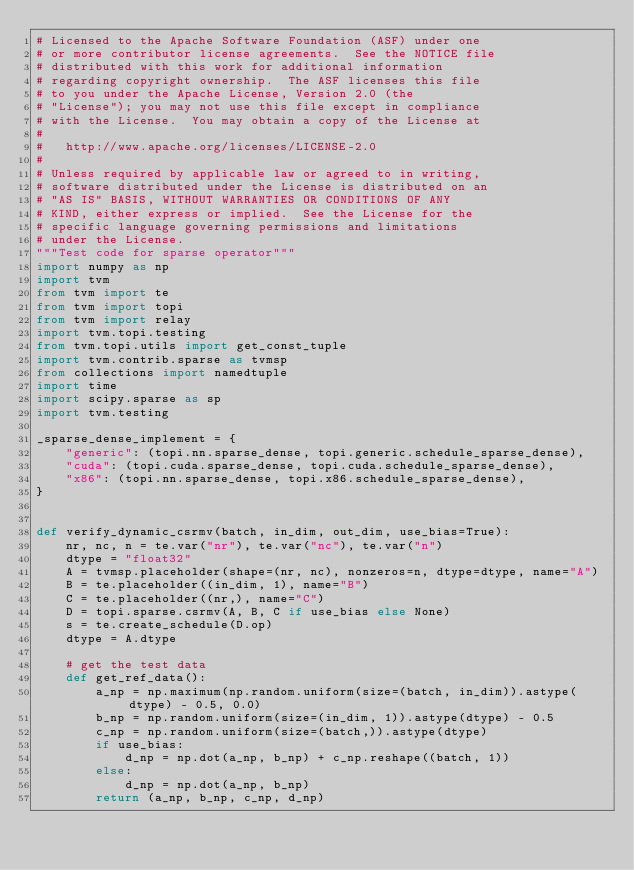<code> <loc_0><loc_0><loc_500><loc_500><_Python_># Licensed to the Apache Software Foundation (ASF) under one
# or more contributor license agreements.  See the NOTICE file
# distributed with this work for additional information
# regarding copyright ownership.  The ASF licenses this file
# to you under the Apache License, Version 2.0 (the
# "License"); you may not use this file except in compliance
# with the License.  You may obtain a copy of the License at
#
#   http://www.apache.org/licenses/LICENSE-2.0
#
# Unless required by applicable law or agreed to in writing,
# software distributed under the License is distributed on an
# "AS IS" BASIS, WITHOUT WARRANTIES OR CONDITIONS OF ANY
# KIND, either express or implied.  See the License for the
# specific language governing permissions and limitations
# under the License.
"""Test code for sparse operator"""
import numpy as np
import tvm
from tvm import te
from tvm import topi
from tvm import relay
import tvm.topi.testing
from tvm.topi.utils import get_const_tuple
import tvm.contrib.sparse as tvmsp
from collections import namedtuple
import time
import scipy.sparse as sp
import tvm.testing

_sparse_dense_implement = {
    "generic": (topi.nn.sparse_dense, topi.generic.schedule_sparse_dense),
    "cuda": (topi.cuda.sparse_dense, topi.cuda.schedule_sparse_dense),
    "x86": (topi.nn.sparse_dense, topi.x86.schedule_sparse_dense),
}


def verify_dynamic_csrmv(batch, in_dim, out_dim, use_bias=True):
    nr, nc, n = te.var("nr"), te.var("nc"), te.var("n")
    dtype = "float32"
    A = tvmsp.placeholder(shape=(nr, nc), nonzeros=n, dtype=dtype, name="A")
    B = te.placeholder((in_dim, 1), name="B")
    C = te.placeholder((nr,), name="C")
    D = topi.sparse.csrmv(A, B, C if use_bias else None)
    s = te.create_schedule(D.op)
    dtype = A.dtype

    # get the test data
    def get_ref_data():
        a_np = np.maximum(np.random.uniform(size=(batch, in_dim)).astype(dtype) - 0.5, 0.0)
        b_np = np.random.uniform(size=(in_dim, 1)).astype(dtype) - 0.5
        c_np = np.random.uniform(size=(batch,)).astype(dtype)
        if use_bias:
            d_np = np.dot(a_np, b_np) + c_np.reshape((batch, 1))
        else:
            d_np = np.dot(a_np, b_np)
        return (a_np, b_np, c_np, d_np)
</code> 